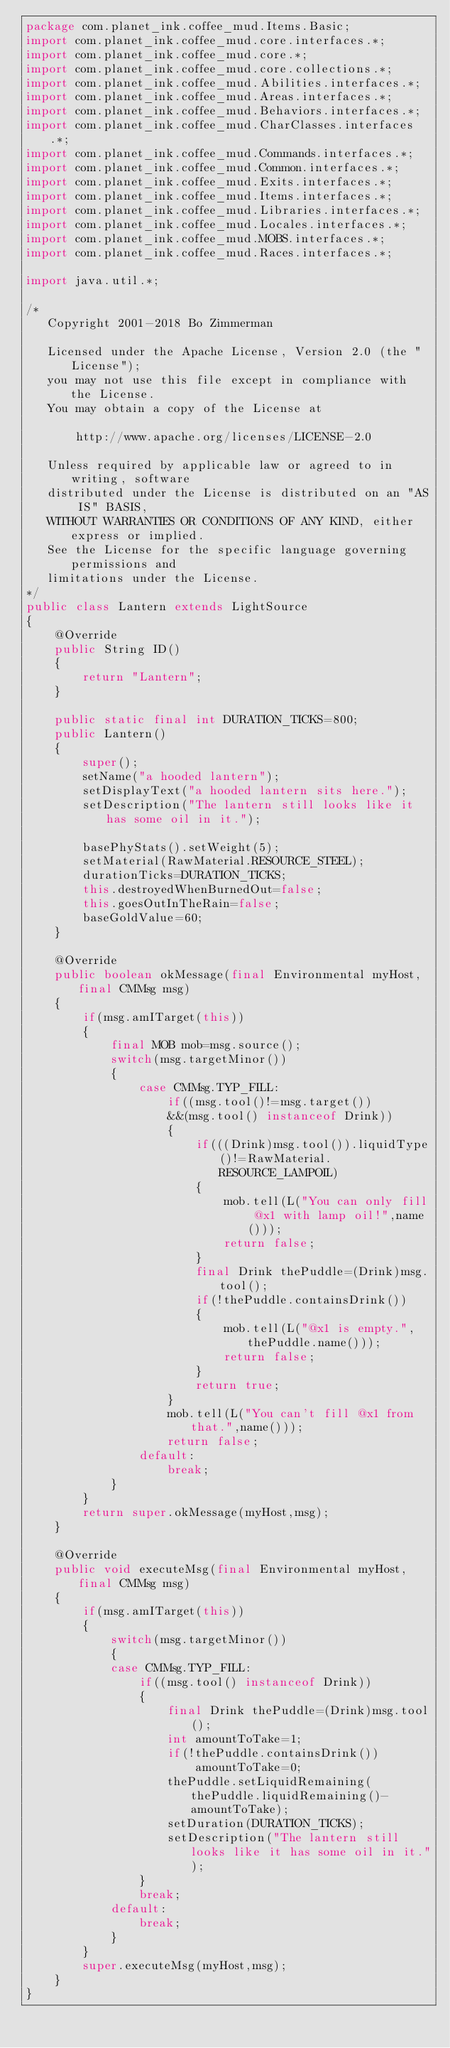Convert code to text. <code><loc_0><loc_0><loc_500><loc_500><_Java_>package com.planet_ink.coffee_mud.Items.Basic;
import com.planet_ink.coffee_mud.core.interfaces.*;
import com.planet_ink.coffee_mud.core.*;
import com.planet_ink.coffee_mud.core.collections.*;
import com.planet_ink.coffee_mud.Abilities.interfaces.*;
import com.planet_ink.coffee_mud.Areas.interfaces.*;
import com.planet_ink.coffee_mud.Behaviors.interfaces.*;
import com.planet_ink.coffee_mud.CharClasses.interfaces.*;
import com.planet_ink.coffee_mud.Commands.interfaces.*;
import com.planet_ink.coffee_mud.Common.interfaces.*;
import com.planet_ink.coffee_mud.Exits.interfaces.*;
import com.planet_ink.coffee_mud.Items.interfaces.*;
import com.planet_ink.coffee_mud.Libraries.interfaces.*;
import com.planet_ink.coffee_mud.Locales.interfaces.*;
import com.planet_ink.coffee_mud.MOBS.interfaces.*;
import com.planet_ink.coffee_mud.Races.interfaces.*;

import java.util.*;

/*
   Copyright 2001-2018 Bo Zimmerman

   Licensed under the Apache License, Version 2.0 (the "License");
   you may not use this file except in compliance with the License.
   You may obtain a copy of the License at

	   http://www.apache.org/licenses/LICENSE-2.0

   Unless required by applicable law or agreed to in writing, software
   distributed under the License is distributed on an "AS IS" BASIS,
   WITHOUT WARRANTIES OR CONDITIONS OF ANY KIND, either express or implied.
   See the License for the specific language governing permissions and
   limitations under the License.
*/
public class Lantern extends LightSource
{
	@Override
	public String ID()
	{
		return "Lantern";
	}

	public static final int DURATION_TICKS=800;
	public Lantern()
	{
		super();
		setName("a hooded lantern");
		setDisplayText("a hooded lantern sits here.");
		setDescription("The lantern still looks like it has some oil in it.");

		basePhyStats().setWeight(5);
		setMaterial(RawMaterial.RESOURCE_STEEL);
		durationTicks=DURATION_TICKS;
		this.destroyedWhenBurnedOut=false;
		this.goesOutInTheRain=false;
		baseGoldValue=60;
	}

	@Override
	public boolean okMessage(final Environmental myHost, final CMMsg msg)
	{
		if(msg.amITarget(this))
		{
			final MOB mob=msg.source();
			switch(msg.targetMinor())
			{
				case CMMsg.TYP_FILL:
					if((msg.tool()!=msg.target())
					&&(msg.tool() instanceof Drink))
					{
						if(((Drink)msg.tool()).liquidType()!=RawMaterial.RESOURCE_LAMPOIL)
						{
							mob.tell(L("You can only fill @x1 with lamp oil!",name()));
							return false;
						}
						final Drink thePuddle=(Drink)msg.tool();
						if(!thePuddle.containsDrink())
						{
							mob.tell(L("@x1 is empty.",thePuddle.name()));
							return false;
						}
						return true;
					}
					mob.tell(L("You can't fill @x1 from that.",name()));
					return false;
				default:
					break;
			}
		}
		return super.okMessage(myHost,msg);
	}

	@Override
	public void executeMsg(final Environmental myHost, final CMMsg msg)
	{
		if(msg.amITarget(this))
		{
			switch(msg.targetMinor())
			{
			case CMMsg.TYP_FILL:
				if((msg.tool() instanceof Drink))
				{
					final Drink thePuddle=(Drink)msg.tool();
					int amountToTake=1;
					if(!thePuddle.containsDrink())
						amountToTake=0;
					thePuddle.setLiquidRemaining(thePuddle.liquidRemaining()-amountToTake);
					setDuration(DURATION_TICKS);
					setDescription("The lantern still looks like it has some oil in it.");
				}
				break;
			default:
				break;
			}
		}
		super.executeMsg(myHost,msg);
	}
}

</code> 